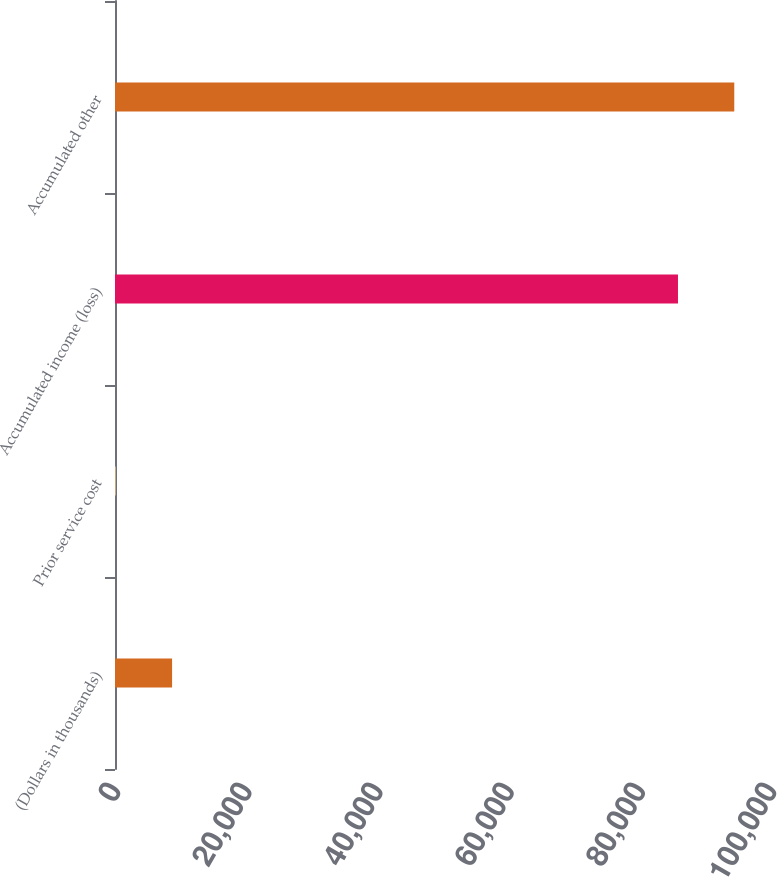Convert chart to OTSL. <chart><loc_0><loc_0><loc_500><loc_500><bar_chart><fcel>(Dollars in thousands)<fcel>Prior service cost<fcel>Accumulated income (loss)<fcel>Accumulated other<nl><fcel>8701<fcel>119<fcel>85820<fcel>94402<nl></chart> 